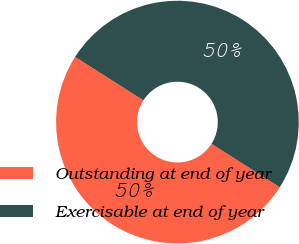<chart> <loc_0><loc_0><loc_500><loc_500><pie_chart><fcel>Outstanding at end of year<fcel>Exercisable at end of year<nl><fcel>50.0%<fcel>50.0%<nl></chart> 